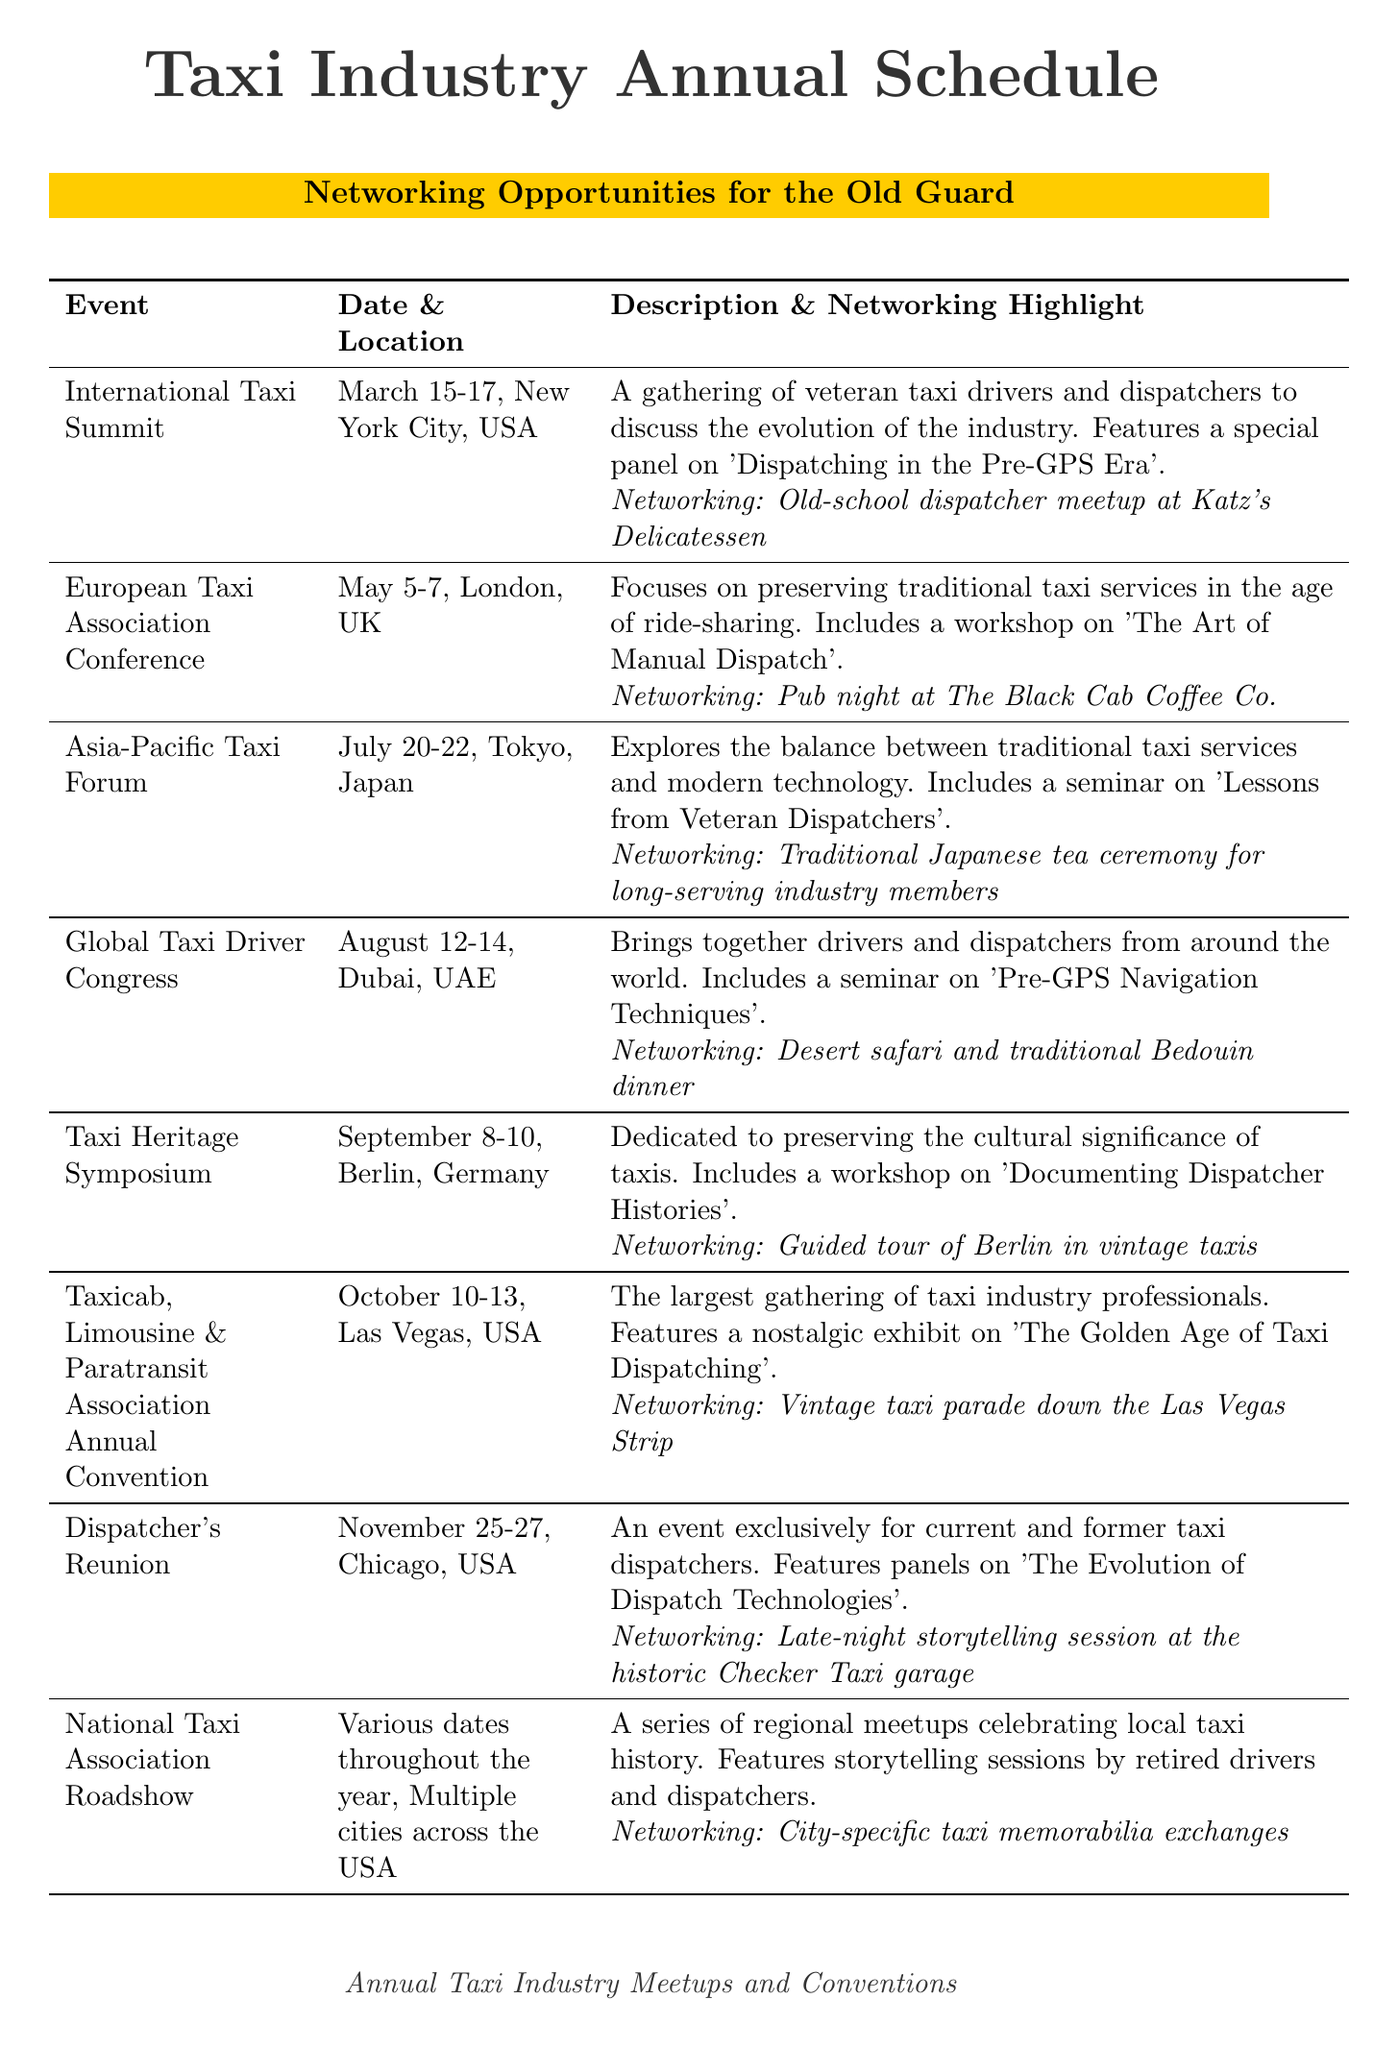What is the date of the International Taxi Summit? The date can be found in the event description of the International Taxi Summit.
Answer: March 15-17 Where is the European Taxi Association Conference held? The location is specified in the details for the European Taxi Association Conference.
Answer: London, UK What is the networking highlight of the Taxicab, Limousine & Paratransit Association Annual Convention? The networking highlight is detailed in the event description for the Taxicab, Limousine & Paratransit Association Annual Convention.
Answer: Vintage taxi parade down the Las Vegas Strip How many days does the Asia-Pacific Taxi Forum last? The duration can be calculated from the given start and end dates of the Asia-Pacific Taxi Forum.
Answer: 3 days What type of event is the Dispatcher’s Reunion? The character of the event can be inferred from the description of the Dispatcher’s Reunion.
Answer: Exclusive for current and former taxi dispatchers Which event focuses on both traditional taxi services and modern technology? This involves reasoning about events that include both aspects in their description.
Answer: Asia-Pacific Taxi Forum What type of memorabilia exchange is mentioned in the National Taxi Association Roadshow? The specific type of exchange can be found in the networking highlight of that event.
Answer: City-specific taxi memorabilia exchanges What is the location of the Taxi Heritage Symposium? The location is directly provided in the event details for the Taxi Heritage Symposium.
Answer: Berlin, Germany What type of workshop is included in the European Taxi Association Conference? The specific type of workshop is stated in the details about the European Taxi Association Conference.
Answer: The Art of Manual Dispatch 